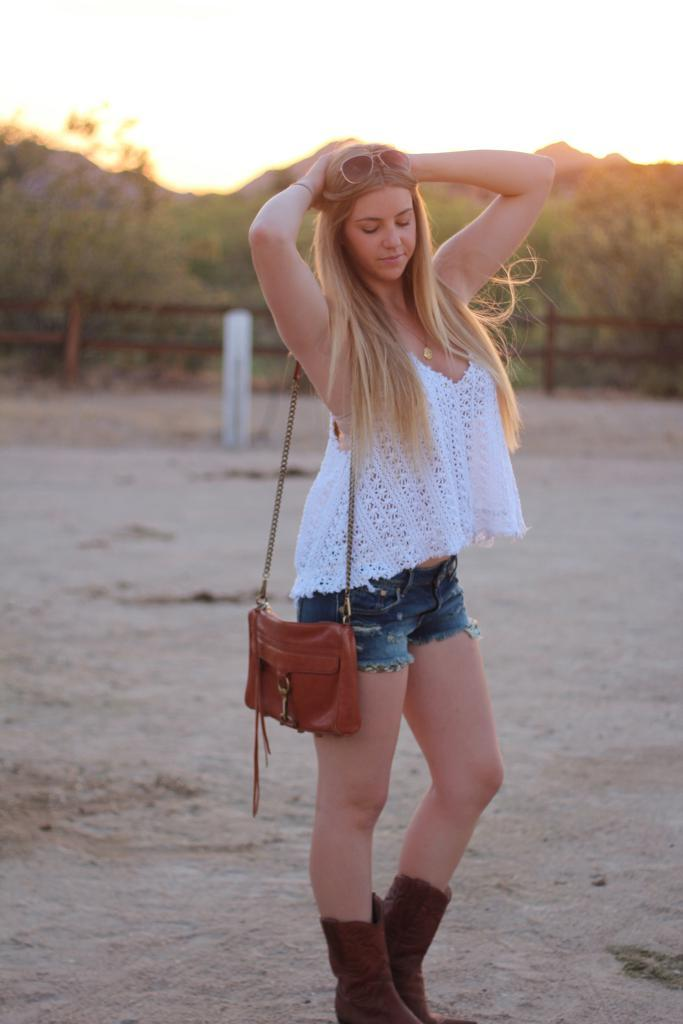What is the main subject of the image? There is a person standing at the center of the image. What can be seen in the background of the image? There are trees visible in the image. Is there any architectural feature present in the image? Yes, there is a fencing in the image. What type of jam is the person holding in the image? There is no jam present in the image. How does the goldfish relate to the person in the image? There is no goldfish present in the image. 